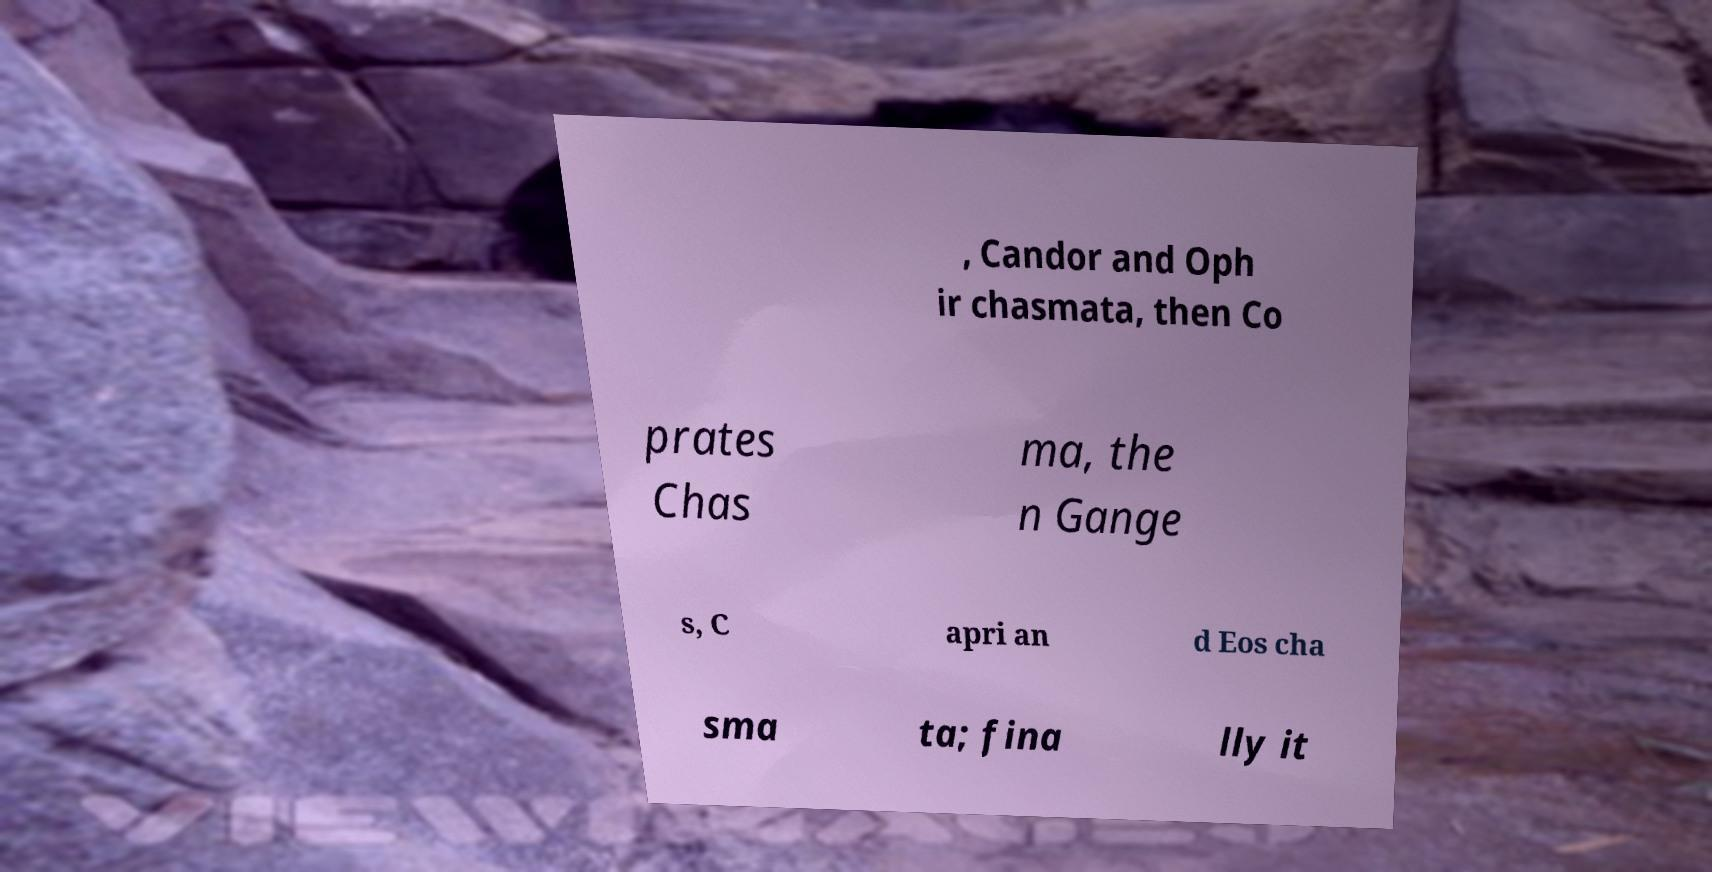What messages or text are displayed in this image? I need them in a readable, typed format. , Candor and Oph ir chasmata, then Co prates Chas ma, the n Gange s, C apri an d Eos cha sma ta; fina lly it 